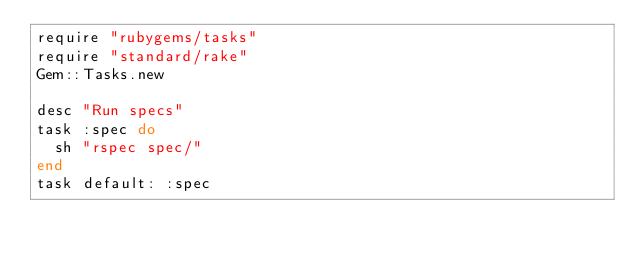<code> <loc_0><loc_0><loc_500><loc_500><_Ruby_>require "rubygems/tasks"
require "standard/rake"
Gem::Tasks.new

desc "Run specs"
task :spec do
  sh "rspec spec/"
end
task default: :spec
</code> 